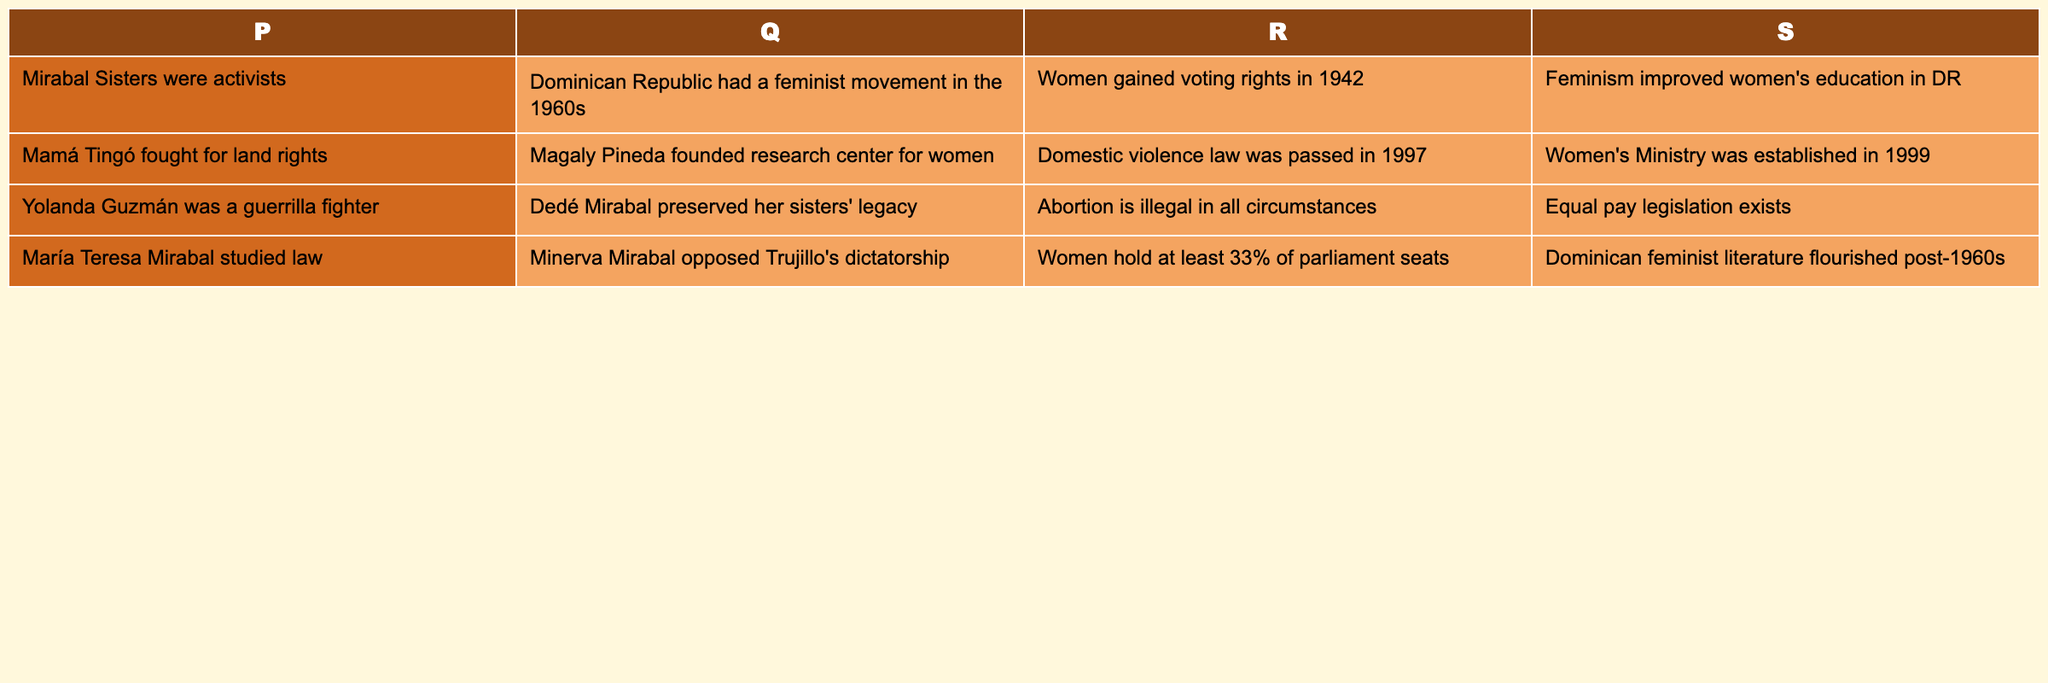What were some actions taken by the Mirabal Sisters? The table indicates that the Mirabal Sisters were activists and that Minerva Mirabal opposed Trujillo's dictatorship. These mention their acts of defiance and activism during a time of political oppression.
Answer: They were activists and opposed Trujillo's dictatorship Did the Dominican Republic have a feminist movement in the 1960s? The table clearly states that "Dominican Republic had a feminist movement in the 1960s", making it a factual retrieval question.
Answer: Yes What is the significance of Mamá Tingó in terms of women's rights? The table shows that Mamá Tingó fought for land rights, highlighting her role in advocating for women's rights, especially regarding land ownership.
Answer: She fought for land rights Is abortion legal under any circumstances in the Dominican Republic? According to the table, it states that "Abortion is illegal in all circumstances", allowing us to answer this fact-based question directly from the data.
Answer: No, it's illegal in all circumstances What is the average number of women holding parliament seats compared to women gaining voting rights? The table shows that women hold at least 33% of parliament seats and gained voting rights in 1942. We need to interpret these numbers, but since the percentage (33%) may not be a direct numerical comparison to a historic year, this question involves comparing two types of data instead of averaging. However, it points to a growing political presence of women since gaining voting rights.
Answer: At least 33% hold seats compared to voting rights secured in 1942 Did any Dominican women contribute to feminist literature after the 1960s? The table states that "Dominican feminist literature flourished post-1960s", confirming the emergence of feminist literature in that era.
Answer: Yes What historical law was passed in 1997? The table specifies that a "Domestic violence law was passed in 1997", making it a straightforward retrieval of a specific fact from the table.
Answer: The Domestic violence law Which year was the Women's Ministry established in the Dominican Republic? The table indicates the establishment of the Women's Ministry occurred in 1999, providing an explicit historical fact directly accessible from the data.
Answer: 1999 What actions or events contributed to women's political empowerment in the Dominican Republic from the information in the table? The table suggests multiple actions: women's voting rights gained in 1942 and the establishment of the Women's Ministry in 1999, along with a growing representation of women in parliament. This chain of events logically supports the claim of political empowerment over time.
Answer: Gaining voting rights in 1942, forming Women's Ministry in 1999, and at least 33% of parliament seats 